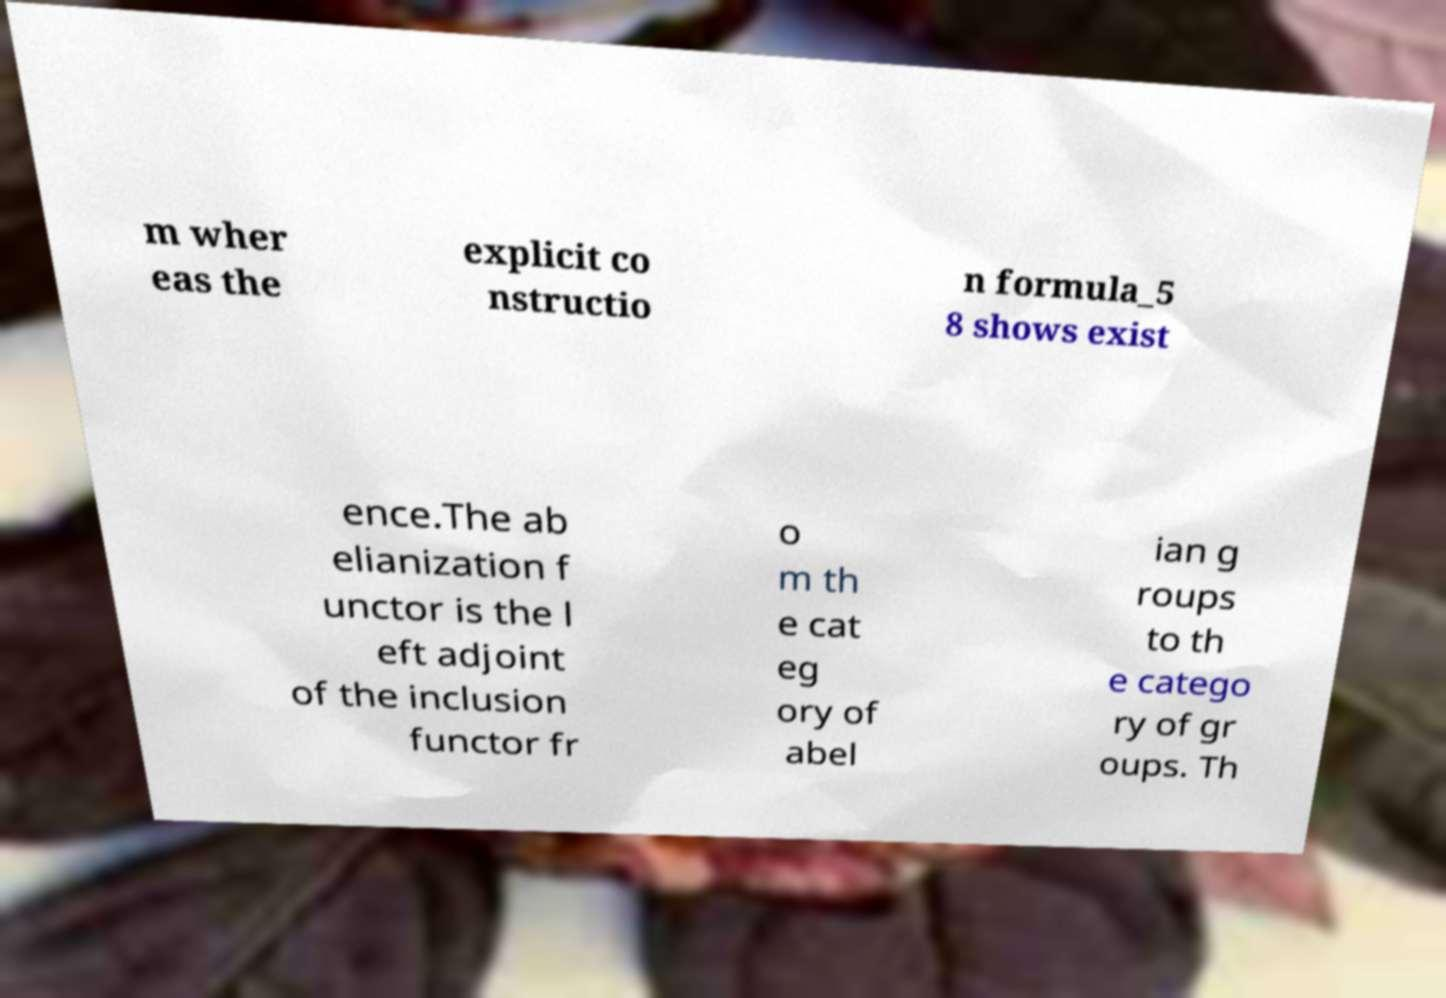Please identify and transcribe the text found in this image. m wher eas the explicit co nstructio n formula_5 8 shows exist ence.The ab elianization f unctor is the l eft adjoint of the inclusion functor fr o m th e cat eg ory of abel ian g roups to th e catego ry of gr oups. Th 